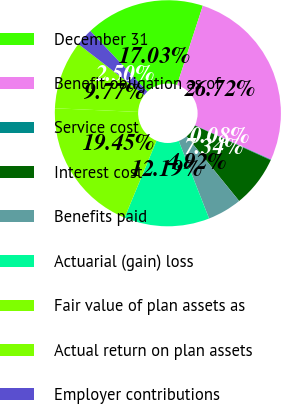Convert chart. <chart><loc_0><loc_0><loc_500><loc_500><pie_chart><fcel>December 31<fcel>Benefit obligation as of<fcel>Service cost<fcel>Interest cost<fcel>Benefits paid<fcel>Actuarial (gain) loss<fcel>Fair value of plan assets as<fcel>Actual return on plan assets<fcel>Employer contributions<nl><fcel>17.03%<fcel>26.72%<fcel>0.08%<fcel>7.34%<fcel>4.92%<fcel>12.19%<fcel>19.45%<fcel>9.77%<fcel>2.5%<nl></chart> 